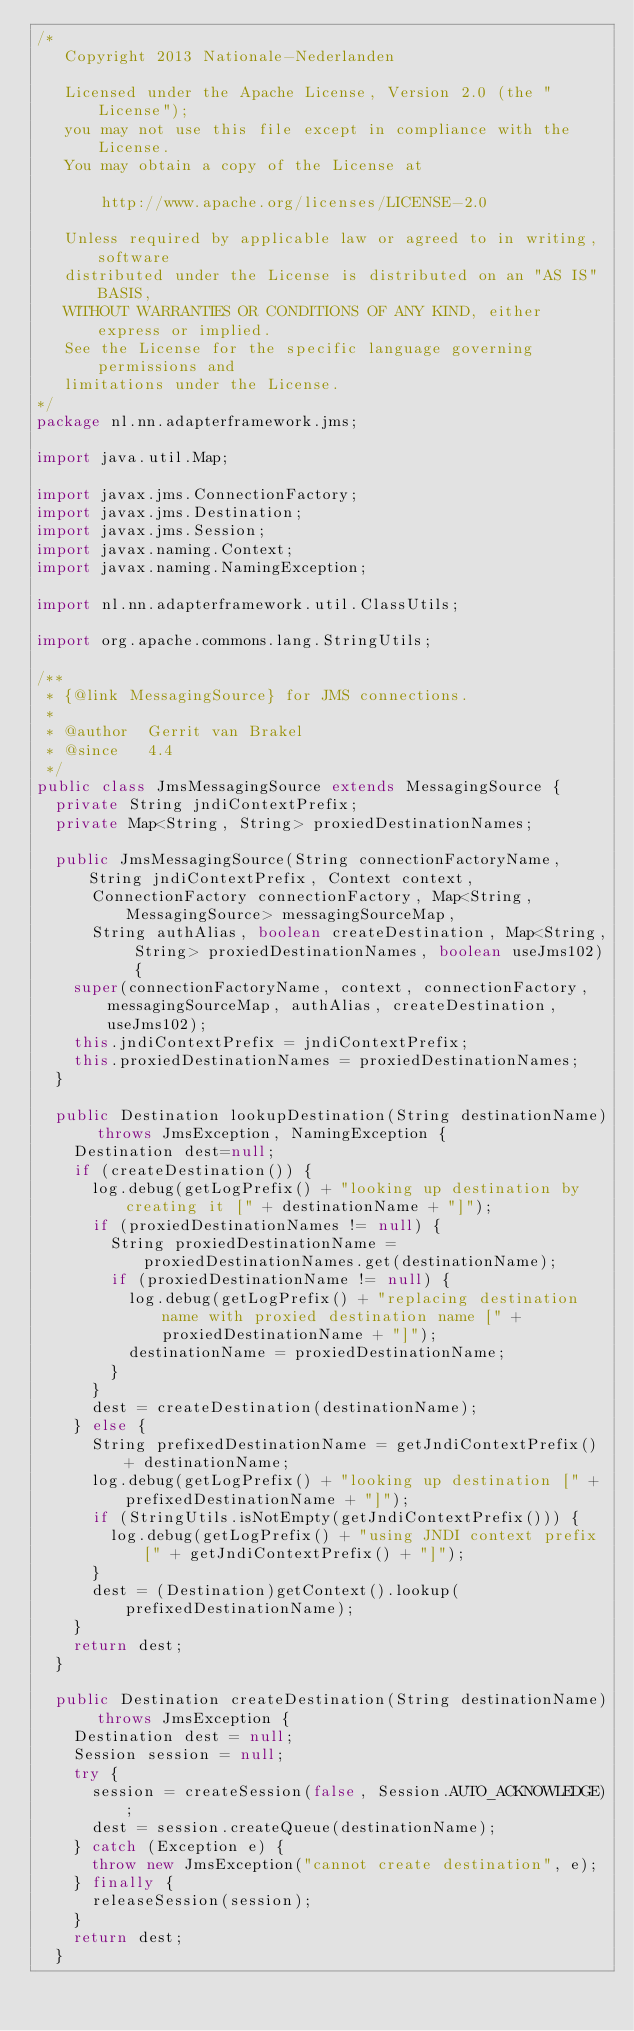Convert code to text. <code><loc_0><loc_0><loc_500><loc_500><_Java_>/*
   Copyright 2013 Nationale-Nederlanden

   Licensed under the Apache License, Version 2.0 (the "License");
   you may not use this file except in compliance with the License.
   You may obtain a copy of the License at

       http://www.apache.org/licenses/LICENSE-2.0

   Unless required by applicable law or agreed to in writing, software
   distributed under the License is distributed on an "AS IS" BASIS,
   WITHOUT WARRANTIES OR CONDITIONS OF ANY KIND, either express or implied.
   See the License for the specific language governing permissions and
   limitations under the License.
*/
package nl.nn.adapterframework.jms;

import java.util.Map;

import javax.jms.ConnectionFactory;
import javax.jms.Destination;
import javax.jms.Session;
import javax.naming.Context;
import javax.naming.NamingException;

import nl.nn.adapterframework.util.ClassUtils;

import org.apache.commons.lang.StringUtils;

/**
 * {@link MessagingSource} for JMS connections.
 * 
 * @author 	Gerrit van Brakel
 * @since   4.4
 */
public class JmsMessagingSource extends MessagingSource {
	private String jndiContextPrefix;
	private Map<String, String> proxiedDestinationNames;

	public JmsMessagingSource(String connectionFactoryName, String jndiContextPrefix, Context context,
			ConnectionFactory connectionFactory, Map<String,MessagingSource> messagingSourceMap,
			String authAlias, boolean createDestination, Map<String, String> proxiedDestinationNames, boolean useJms102) {
		super(connectionFactoryName, context, connectionFactory, messagingSourceMap, authAlias, createDestination, useJms102);
		this.jndiContextPrefix = jndiContextPrefix;
		this.proxiedDestinationNames = proxiedDestinationNames;
	}

	public Destination lookupDestination(String destinationName) throws JmsException, NamingException {
		Destination dest=null;
		if (createDestination()) {
			log.debug(getLogPrefix() + "looking up destination by creating it [" + destinationName + "]");
			if (proxiedDestinationNames != null) {
				String proxiedDestinationName = proxiedDestinationNames.get(destinationName);
				if (proxiedDestinationName != null) {
					log.debug(getLogPrefix() + "replacing destination name with proxied destination name [" + proxiedDestinationName + "]");
					destinationName = proxiedDestinationName;
				}
			}
			dest = createDestination(destinationName);
		} else {
			String prefixedDestinationName = getJndiContextPrefix() + destinationName;
			log.debug(getLogPrefix() + "looking up destination [" + prefixedDestinationName + "]");
			if (StringUtils.isNotEmpty(getJndiContextPrefix())) {
				log.debug(getLogPrefix() + "using JNDI context prefix [" + getJndiContextPrefix() + "]");
			}
			dest = (Destination)getContext().lookup(prefixedDestinationName);
		}
		return dest;
	}

	public Destination createDestination(String destinationName) throws JmsException {
		Destination dest = null;
		Session session = null;
		try {
			session = createSession(false, Session.AUTO_ACKNOWLEDGE);
			dest = session.createQueue(destinationName);
		} catch (Exception e) {
			throw new JmsException("cannot create destination", e);
		} finally {
			releaseSession(session);
		}
		return dest;
	}
	</code> 